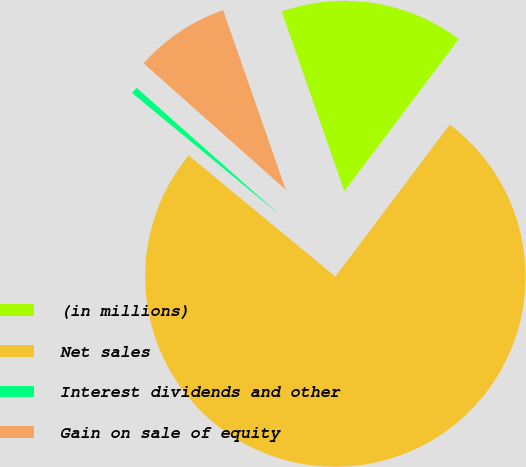Convert chart to OTSL. <chart><loc_0><loc_0><loc_500><loc_500><pie_chart><fcel>(in millions)<fcel>Net sales<fcel>Interest dividends and other<fcel>Gain on sale of equity<nl><fcel>15.61%<fcel>75.72%<fcel>0.58%<fcel>8.09%<nl></chart> 